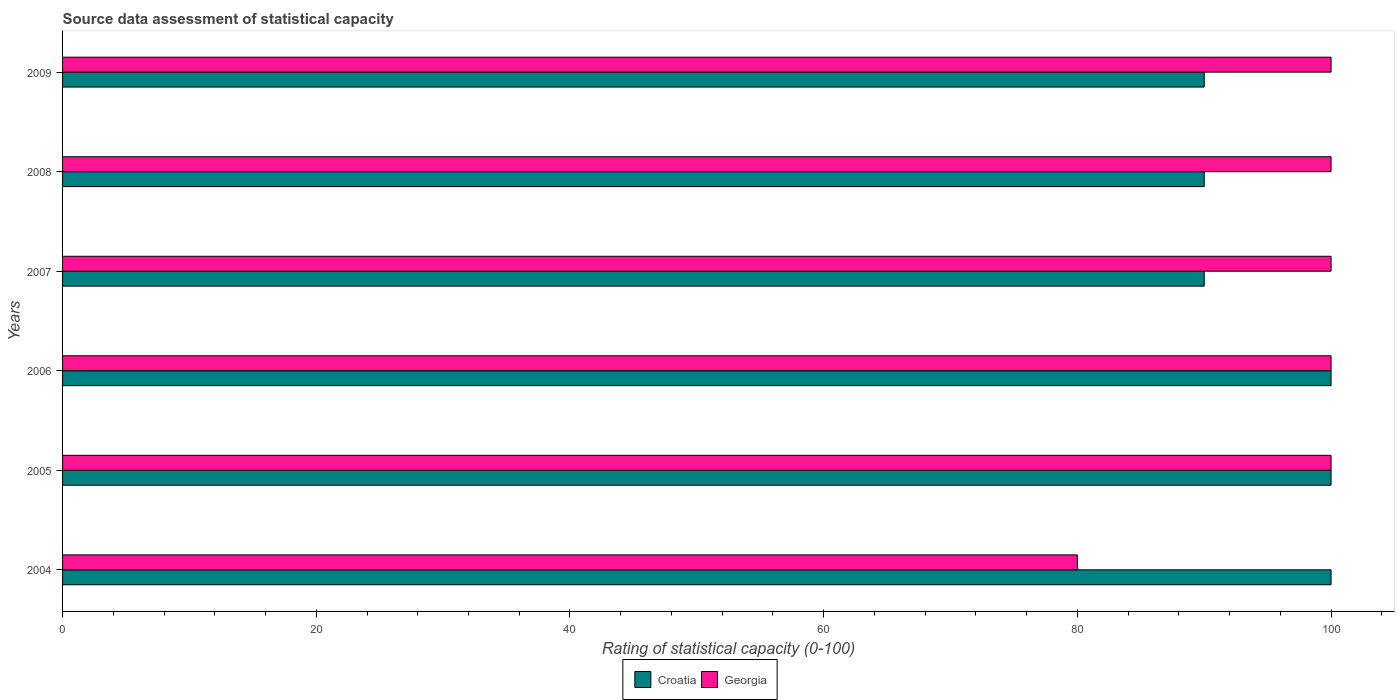How many different coloured bars are there?
Your answer should be compact. 2. How many bars are there on the 1st tick from the top?
Your response must be concise. 2. What is the label of the 6th group of bars from the top?
Your response must be concise. 2004. In how many cases, is the number of bars for a given year not equal to the number of legend labels?
Your answer should be very brief. 0. What is the rating of statistical capacity in Georgia in 2006?
Offer a terse response. 100. Across all years, what is the maximum rating of statistical capacity in Georgia?
Provide a short and direct response. 100. Across all years, what is the minimum rating of statistical capacity in Georgia?
Your answer should be very brief. 80. In which year was the rating of statistical capacity in Georgia minimum?
Ensure brevity in your answer.  2004. What is the total rating of statistical capacity in Croatia in the graph?
Your response must be concise. 570. What is the difference between the rating of statistical capacity in Croatia in 2008 and the rating of statistical capacity in Georgia in 2007?
Ensure brevity in your answer.  -10. What is the average rating of statistical capacity in Georgia per year?
Your answer should be very brief. 96.67. In the year 2007, what is the difference between the rating of statistical capacity in Georgia and rating of statistical capacity in Croatia?
Keep it short and to the point. 10. In how many years, is the rating of statistical capacity in Croatia greater than 96 ?
Keep it short and to the point. 3. What is the ratio of the rating of statistical capacity in Georgia in 2007 to that in 2009?
Your response must be concise. 1. Is the rating of statistical capacity in Georgia in 2006 less than that in 2007?
Provide a succinct answer. No. Is the difference between the rating of statistical capacity in Georgia in 2004 and 2006 greater than the difference between the rating of statistical capacity in Croatia in 2004 and 2006?
Offer a terse response. No. What is the difference between the highest and the lowest rating of statistical capacity in Croatia?
Provide a short and direct response. 10. In how many years, is the rating of statistical capacity in Croatia greater than the average rating of statistical capacity in Croatia taken over all years?
Offer a very short reply. 3. What does the 1st bar from the top in 2009 represents?
Offer a terse response. Georgia. What does the 2nd bar from the bottom in 2007 represents?
Offer a very short reply. Georgia. How many years are there in the graph?
Your response must be concise. 6. What is the difference between two consecutive major ticks on the X-axis?
Your answer should be compact. 20. Does the graph contain any zero values?
Ensure brevity in your answer.  No. Does the graph contain grids?
Give a very brief answer. No. How many legend labels are there?
Your answer should be very brief. 2. What is the title of the graph?
Make the answer very short. Source data assessment of statistical capacity. Does "Bolivia" appear as one of the legend labels in the graph?
Your answer should be compact. No. What is the label or title of the X-axis?
Your response must be concise. Rating of statistical capacity (0-100). What is the label or title of the Y-axis?
Your answer should be very brief. Years. What is the Rating of statistical capacity (0-100) of Georgia in 2004?
Make the answer very short. 80. What is the Rating of statistical capacity (0-100) of Croatia in 2005?
Ensure brevity in your answer.  100. What is the Rating of statistical capacity (0-100) of Georgia in 2005?
Provide a succinct answer. 100. What is the Rating of statistical capacity (0-100) in Georgia in 2006?
Your answer should be very brief. 100. What is the Rating of statistical capacity (0-100) of Georgia in 2007?
Your response must be concise. 100. What is the Rating of statistical capacity (0-100) of Georgia in 2008?
Your answer should be compact. 100. What is the Rating of statistical capacity (0-100) of Georgia in 2009?
Your response must be concise. 100. What is the total Rating of statistical capacity (0-100) of Croatia in the graph?
Provide a succinct answer. 570. What is the total Rating of statistical capacity (0-100) in Georgia in the graph?
Offer a very short reply. 580. What is the difference between the Rating of statistical capacity (0-100) in Croatia in 2004 and that in 2005?
Offer a very short reply. 0. What is the difference between the Rating of statistical capacity (0-100) of Georgia in 2004 and that in 2005?
Your answer should be very brief. -20. What is the difference between the Rating of statistical capacity (0-100) of Georgia in 2004 and that in 2006?
Make the answer very short. -20. What is the difference between the Rating of statistical capacity (0-100) of Georgia in 2004 and that in 2007?
Keep it short and to the point. -20. What is the difference between the Rating of statistical capacity (0-100) of Croatia in 2004 and that in 2008?
Your answer should be very brief. 10. What is the difference between the Rating of statistical capacity (0-100) in Croatia in 2004 and that in 2009?
Offer a terse response. 10. What is the difference between the Rating of statistical capacity (0-100) of Croatia in 2005 and that in 2006?
Offer a very short reply. 0. What is the difference between the Rating of statistical capacity (0-100) in Georgia in 2005 and that in 2006?
Make the answer very short. 0. What is the difference between the Rating of statistical capacity (0-100) in Croatia in 2005 and that in 2007?
Offer a very short reply. 10. What is the difference between the Rating of statistical capacity (0-100) in Croatia in 2005 and that in 2008?
Provide a succinct answer. 10. What is the difference between the Rating of statistical capacity (0-100) of Georgia in 2005 and that in 2008?
Provide a succinct answer. 0. What is the difference between the Rating of statistical capacity (0-100) of Georgia in 2005 and that in 2009?
Keep it short and to the point. 0. What is the difference between the Rating of statistical capacity (0-100) of Georgia in 2006 and that in 2007?
Provide a succinct answer. 0. What is the difference between the Rating of statistical capacity (0-100) of Georgia in 2006 and that in 2008?
Offer a terse response. 0. What is the difference between the Rating of statistical capacity (0-100) of Georgia in 2006 and that in 2009?
Give a very brief answer. 0. What is the difference between the Rating of statistical capacity (0-100) of Croatia in 2007 and that in 2008?
Offer a very short reply. 0. What is the difference between the Rating of statistical capacity (0-100) of Georgia in 2007 and that in 2008?
Offer a terse response. 0. What is the difference between the Rating of statistical capacity (0-100) in Georgia in 2007 and that in 2009?
Ensure brevity in your answer.  0. What is the difference between the Rating of statistical capacity (0-100) of Croatia in 2008 and that in 2009?
Your answer should be very brief. 0. What is the difference between the Rating of statistical capacity (0-100) in Croatia in 2004 and the Rating of statistical capacity (0-100) in Georgia in 2007?
Provide a short and direct response. 0. What is the difference between the Rating of statistical capacity (0-100) of Croatia in 2004 and the Rating of statistical capacity (0-100) of Georgia in 2008?
Make the answer very short. 0. What is the difference between the Rating of statistical capacity (0-100) of Croatia in 2005 and the Rating of statistical capacity (0-100) of Georgia in 2008?
Keep it short and to the point. 0. What is the difference between the Rating of statistical capacity (0-100) in Croatia in 2006 and the Rating of statistical capacity (0-100) in Georgia in 2007?
Keep it short and to the point. 0. What is the difference between the Rating of statistical capacity (0-100) of Croatia in 2006 and the Rating of statistical capacity (0-100) of Georgia in 2009?
Keep it short and to the point. 0. What is the difference between the Rating of statistical capacity (0-100) in Croatia in 2007 and the Rating of statistical capacity (0-100) in Georgia in 2008?
Offer a terse response. -10. What is the average Rating of statistical capacity (0-100) in Georgia per year?
Your answer should be very brief. 96.67. In the year 2004, what is the difference between the Rating of statistical capacity (0-100) in Croatia and Rating of statistical capacity (0-100) in Georgia?
Provide a short and direct response. 20. What is the ratio of the Rating of statistical capacity (0-100) of Croatia in 2004 to that in 2005?
Offer a very short reply. 1. What is the ratio of the Rating of statistical capacity (0-100) of Georgia in 2004 to that in 2005?
Your answer should be compact. 0.8. What is the ratio of the Rating of statistical capacity (0-100) in Croatia in 2004 to that in 2006?
Ensure brevity in your answer.  1. What is the ratio of the Rating of statistical capacity (0-100) in Georgia in 2004 to that in 2007?
Offer a terse response. 0.8. What is the ratio of the Rating of statistical capacity (0-100) in Croatia in 2004 to that in 2008?
Give a very brief answer. 1.11. What is the ratio of the Rating of statistical capacity (0-100) in Croatia in 2004 to that in 2009?
Provide a short and direct response. 1.11. What is the ratio of the Rating of statistical capacity (0-100) of Georgia in 2004 to that in 2009?
Offer a terse response. 0.8. What is the ratio of the Rating of statistical capacity (0-100) in Croatia in 2005 to that in 2006?
Give a very brief answer. 1. What is the ratio of the Rating of statistical capacity (0-100) of Georgia in 2005 to that in 2006?
Your response must be concise. 1. What is the ratio of the Rating of statistical capacity (0-100) in Georgia in 2005 to that in 2007?
Your answer should be compact. 1. What is the ratio of the Rating of statistical capacity (0-100) of Croatia in 2005 to that in 2008?
Provide a short and direct response. 1.11. What is the ratio of the Rating of statistical capacity (0-100) in Georgia in 2005 to that in 2008?
Offer a very short reply. 1. What is the ratio of the Rating of statistical capacity (0-100) of Georgia in 2005 to that in 2009?
Your answer should be compact. 1. What is the ratio of the Rating of statistical capacity (0-100) of Croatia in 2006 to that in 2007?
Make the answer very short. 1.11. What is the ratio of the Rating of statistical capacity (0-100) in Croatia in 2006 to that in 2008?
Your response must be concise. 1.11. What is the ratio of the Rating of statistical capacity (0-100) in Croatia in 2006 to that in 2009?
Offer a terse response. 1.11. What is the ratio of the Rating of statistical capacity (0-100) of Georgia in 2006 to that in 2009?
Your answer should be very brief. 1. What is the ratio of the Rating of statistical capacity (0-100) of Croatia in 2007 to that in 2008?
Your answer should be very brief. 1. What is the ratio of the Rating of statistical capacity (0-100) of Georgia in 2007 to that in 2008?
Provide a short and direct response. 1. What is the ratio of the Rating of statistical capacity (0-100) of Croatia in 2007 to that in 2009?
Offer a terse response. 1. What is the ratio of the Rating of statistical capacity (0-100) in Croatia in 2008 to that in 2009?
Provide a succinct answer. 1. What is the difference between the highest and the second highest Rating of statistical capacity (0-100) of Croatia?
Ensure brevity in your answer.  0. What is the difference between the highest and the lowest Rating of statistical capacity (0-100) of Croatia?
Your response must be concise. 10. 